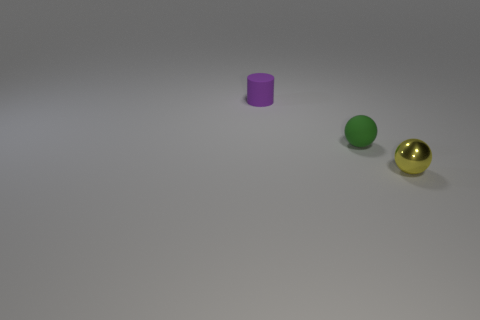Subtract all cylinders. How many objects are left? 2 Add 1 green rubber things. How many objects exist? 4 Subtract all purple matte objects. Subtract all small green matte balls. How many objects are left? 1 Add 1 matte balls. How many matte balls are left? 2 Add 3 small yellow rubber objects. How many small yellow rubber objects exist? 3 Subtract 1 purple cylinders. How many objects are left? 2 